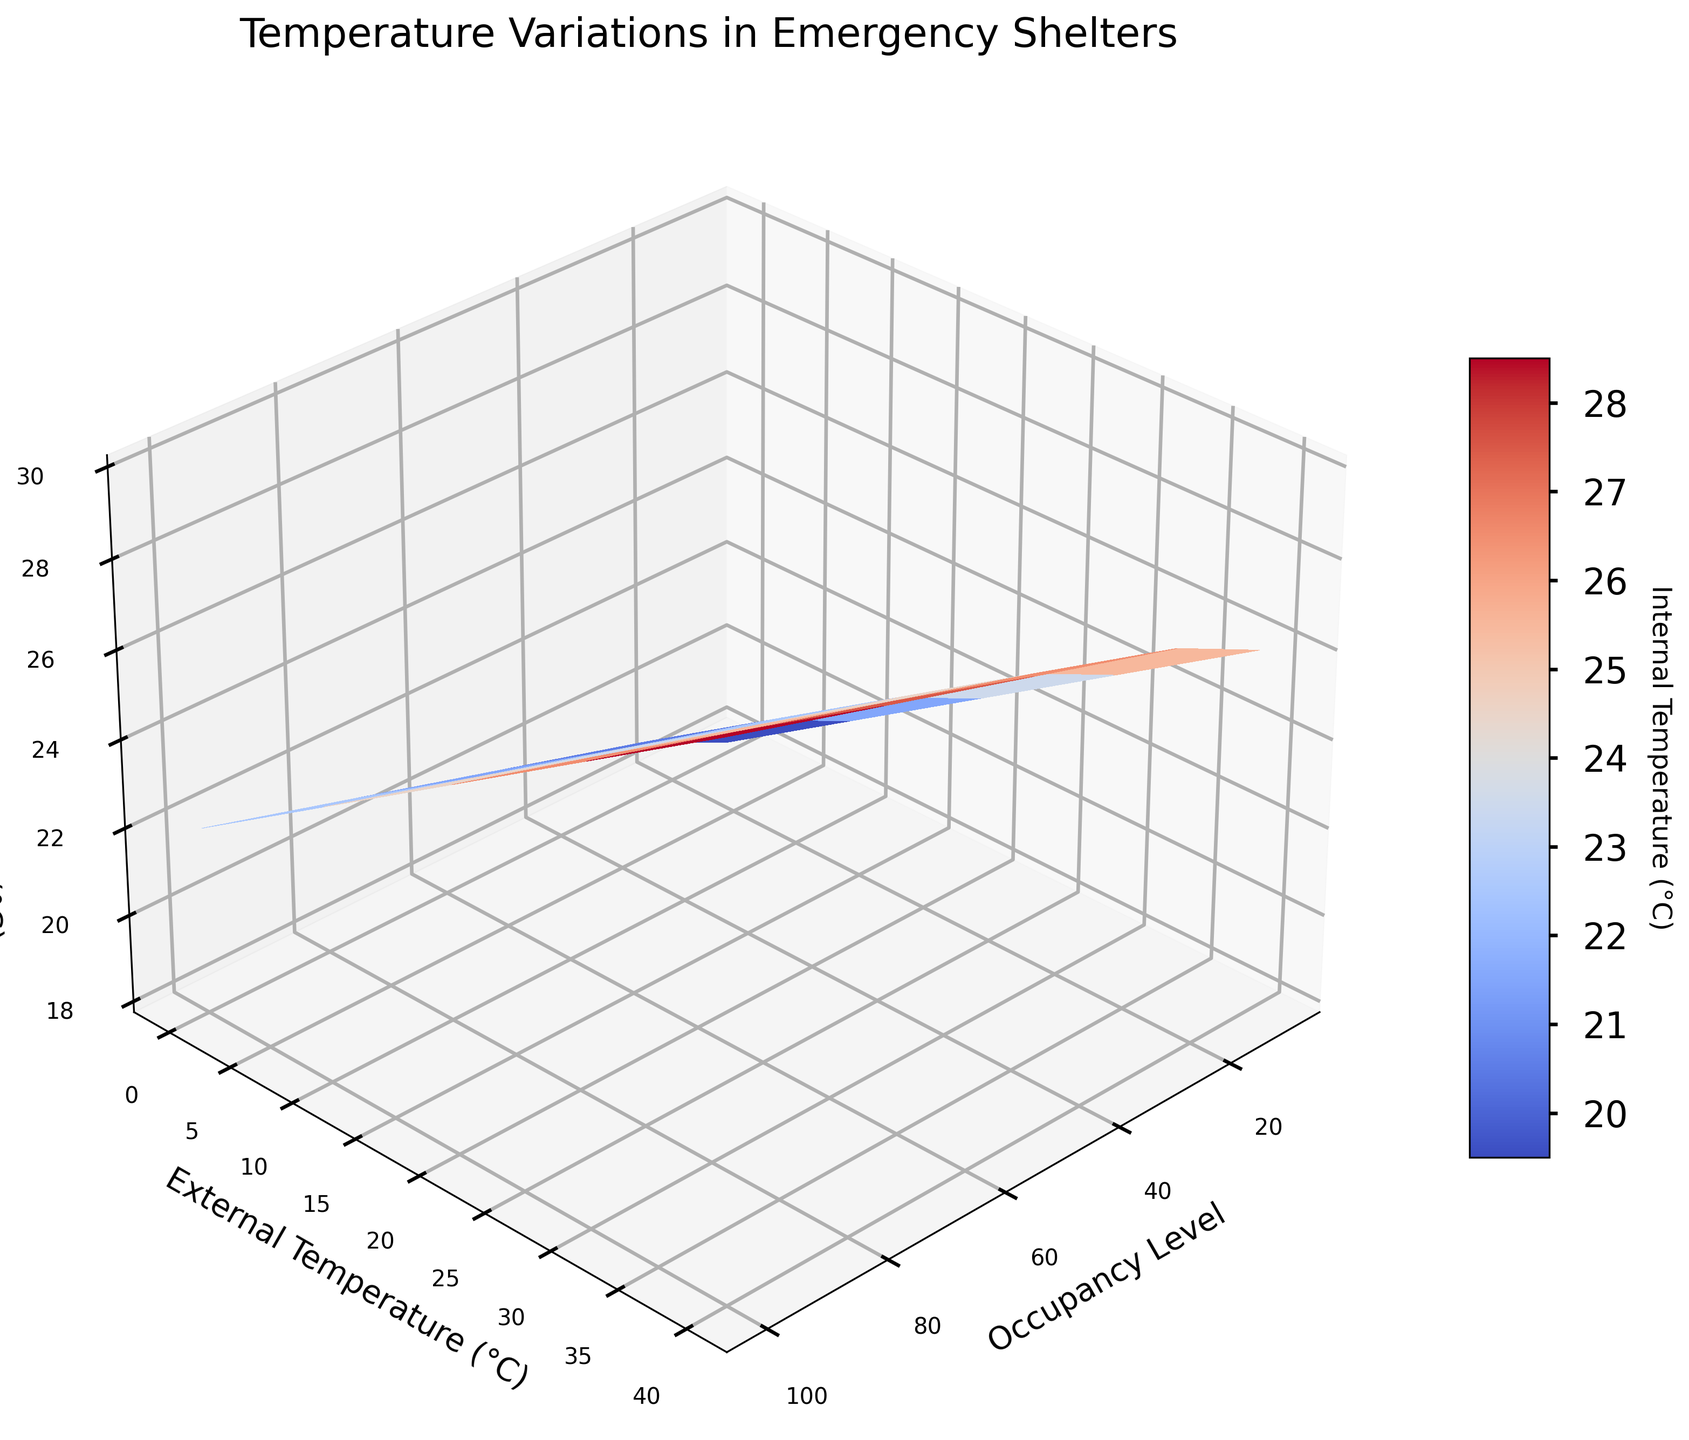What does the title of the figure say? The title of the figure, which is usually at the top, provides the context or topic the plot is addressing. In this case, it reads "Temperature Variations in Emergency Shelters".
Answer: Temperature Variations in Emergency Shelters What are the labels of the axes in the plot? The axis labels provide information on what the data dimensions represent. Here, the x-axis is labeled "Occupancy Level", the y-axis is labeled "External Temperature (°C)", and the z-axis is labeled "Internal Temperature (°C)".
Answer: Occupancy Level, External Temperature (°C), Internal Temperature (°C) Which occupancy level shows the highest internal temperature when the external temperature is 40°C? Observing the plot, find the highest z-value (Internal Temperature) along the y-line (External Temperature) of 40°C. The peak occurs at the highest occupancy level on the x-axis, which in this case is 100.
Answer: 100 How does the internal temperature change as the external temperature increases from 0°C to 40°C at an occupancy level of 25? Track the z-values along the specific x-value (Occupancy Level) of 25 while increasing the y-value (External Temperature) from 0°C to 40°C. The internal temperature values increase from 19°C to 27°C as the external temperature rises.
Answer: From 19°C to 27°C What is the internal temperature at an occupancy level of 50 and an external temperature of 0°C? Locate the intersection of occupancy level 50 on the x-axis and external temperature 0°C on the y-axis, then read the internal temperature (z-axis) at this point. It is 20°C.
Answer: 20°C Compare the internal temperature difference between occupancy levels 10 and 100 when the external temperature is 20°C Find the internal temperatures for both occupancy levels 10 and 100 at 20°C external temperature: 22°C and 26°C respectively. The difference is computed by subtracting the smaller value from the larger one: 26°C - 22°C = 4°C.
Answer: 4°C What’s the average internal temperature at an occupancy level of 75? Sum the internal temperatures for an occupancy level of 75 across all external temperatures and divide by the number of data points. The values are 21°C, 23°C, 25°C, 27°C, and 29°C. The average is (21 + 23 + 25 + 27 + 29)/5 = 25°C.
Answer: 25°C How does the color of the surface plot change as the internal temperature increases? The colormap used is cm.coolwarm, which typically transitions from blue indicating lower temperatures to red representing higher temperatures. Observing the color gradient on the plot, it transitions from blue to red as the internal temperature increases.
Answer: From blue to red Does the internal temperature increase linearly with external temperature for all occupancy levels? Examine the trend of internal temperatures across various external temperatures for different occupancy levels. The lines on the z-axis do show an increase, but the increase is not strictly linear as there are slight variations in the rate of temperature changes.
Answer: No 